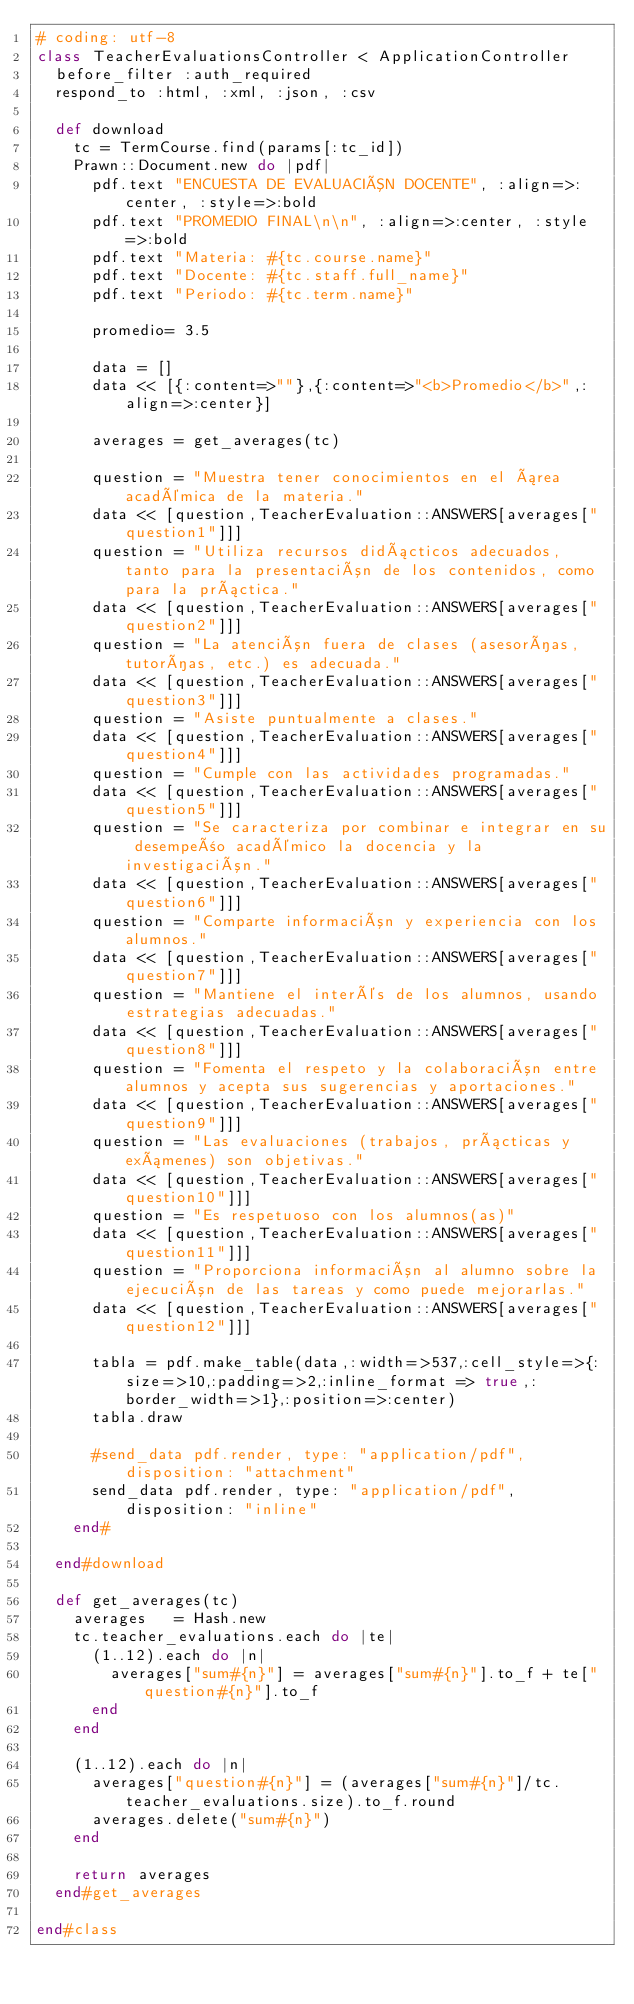<code> <loc_0><loc_0><loc_500><loc_500><_Ruby_># coding: utf-8
class TeacherEvaluationsController < ApplicationController
  before_filter :auth_required
  respond_to :html, :xml, :json, :csv

  def download
    tc = TermCourse.find(params[:tc_id])
    Prawn::Document.new do |pdf|
      pdf.text "ENCUESTA DE EVALUACIÓN DOCENTE", :align=>:center, :style=>:bold
      pdf.text "PROMEDIO FINAL\n\n", :align=>:center, :style=>:bold
      pdf.text "Materia: #{tc.course.name}"
      pdf.text "Docente: #{tc.staff.full_name}"
      pdf.text "Periodo: #{tc.term.name}"

      promedio= 3.5

      data = []
      data << [{:content=>""},{:content=>"<b>Promedio</b>",:align=>:center}]

      averages = get_averages(tc)

      question = "Muestra tener conocimientos en el área académica de la materia."
      data << [question,TeacherEvaluation::ANSWERS[averages["question1"]]]
      question = "Utiliza recursos didácticos adecuados, tanto para la presentación de los contenidos, como para la práctica."
      data << [question,TeacherEvaluation::ANSWERS[averages["question2"]]]
      question = "La atención fuera de clases (asesorías, tutorías, etc.) es adecuada."
      data << [question,TeacherEvaluation::ANSWERS[averages["question3"]]]
      question = "Asiste puntualmente a clases."
      data << [question,TeacherEvaluation::ANSWERS[averages["question4"]]]
      question = "Cumple con las actividades programadas."
      data << [question,TeacherEvaluation::ANSWERS[averages["question5"]]]
      question = "Se caracteriza por combinar e integrar en su desempeño académico la docencia y la investigación."
      data << [question,TeacherEvaluation::ANSWERS[averages["question6"]]]
      question = "Comparte información y experiencia con los alumnos."
      data << [question,TeacherEvaluation::ANSWERS[averages["question7"]]]
      question = "Mantiene el interés de los alumnos, usando estrategias adecuadas."
      data << [question,TeacherEvaluation::ANSWERS[averages["question8"]]]
      question = "Fomenta el respeto y la colaboración entre alumnos y acepta sus sugerencias y aportaciones."
      data << [question,TeacherEvaluation::ANSWERS[averages["question9"]]]
      question = "Las evaluaciones (trabajos, prácticas y exámenes) son objetivas."
      data << [question,TeacherEvaluation::ANSWERS[averages["question10"]]]
      question = "Es respetuoso con los alumnos(as)"
      data << [question,TeacherEvaluation::ANSWERS[averages["question11"]]]
      question = "Proporciona información al alumno sobre la ejecución de las tareas y como puede mejorarlas."
      data << [question,TeacherEvaluation::ANSWERS[averages["question12"]]]

      tabla = pdf.make_table(data,:width=>537,:cell_style=>{:size=>10,:padding=>2,:inline_format => true,:border_width=>1},:position=>:center)
      tabla.draw

      #send_data pdf.render, type: "application/pdf", disposition: "attachment"
      send_data pdf.render, type: "application/pdf", disposition: "inline"
    end#

  end#download

  def get_averages(tc)
    averages   = Hash.new
    tc.teacher_evaluations.each do |te|
      (1..12).each do |n|
        averages["sum#{n}"] = averages["sum#{n}"].to_f + te["question#{n}"].to_f
      end
    end
      
    (1..12).each do |n|
      averages["question#{n}"] = (averages["sum#{n}"]/tc.teacher_evaluations.size).to_f.round
      averages.delete("sum#{n}")
    end
    
    return averages
  end#get_averages
  
end#class
</code> 